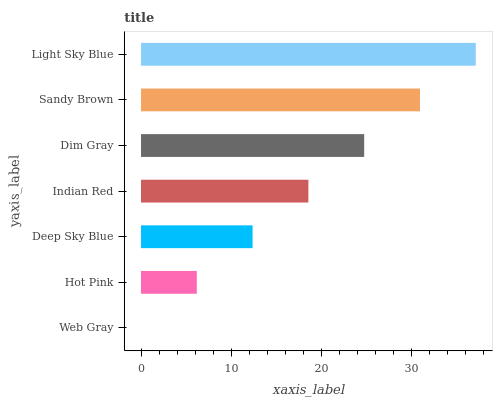Is Web Gray the minimum?
Answer yes or no. Yes. Is Light Sky Blue the maximum?
Answer yes or no. Yes. Is Hot Pink the minimum?
Answer yes or no. No. Is Hot Pink the maximum?
Answer yes or no. No. Is Hot Pink greater than Web Gray?
Answer yes or no. Yes. Is Web Gray less than Hot Pink?
Answer yes or no. Yes. Is Web Gray greater than Hot Pink?
Answer yes or no. No. Is Hot Pink less than Web Gray?
Answer yes or no. No. Is Indian Red the high median?
Answer yes or no. Yes. Is Indian Red the low median?
Answer yes or no. Yes. Is Hot Pink the high median?
Answer yes or no. No. Is Dim Gray the low median?
Answer yes or no. No. 